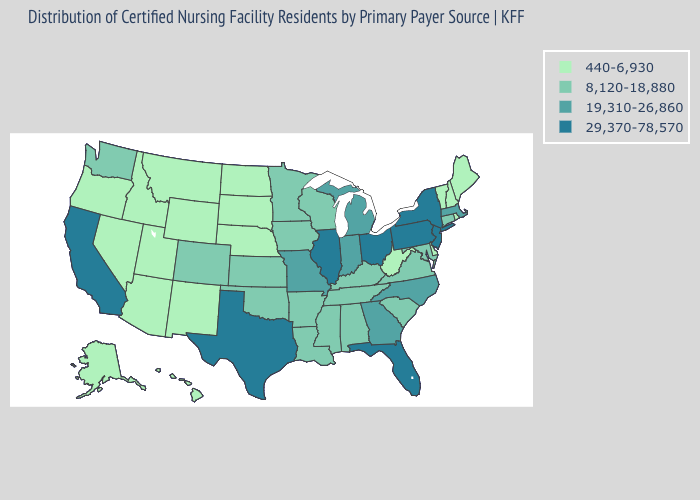Among the states that border Rhode Island , does Connecticut have the lowest value?
Quick response, please. Yes. What is the value of Pennsylvania?
Write a very short answer. 29,370-78,570. Does the first symbol in the legend represent the smallest category?
Be succinct. Yes. What is the value of Washington?
Keep it brief. 8,120-18,880. Name the states that have a value in the range 440-6,930?
Quick response, please. Alaska, Arizona, Delaware, Hawaii, Idaho, Maine, Montana, Nebraska, Nevada, New Hampshire, New Mexico, North Dakota, Oregon, Rhode Island, South Dakota, Utah, Vermont, West Virginia, Wyoming. Does the map have missing data?
Concise answer only. No. Which states have the highest value in the USA?
Keep it brief. California, Florida, Illinois, New Jersey, New York, Ohio, Pennsylvania, Texas. What is the value of Montana?
Write a very short answer. 440-6,930. Which states hav the highest value in the West?
Keep it brief. California. What is the value of South Carolina?
Answer briefly. 8,120-18,880. Name the states that have a value in the range 8,120-18,880?
Quick response, please. Alabama, Arkansas, Colorado, Connecticut, Iowa, Kansas, Kentucky, Louisiana, Maryland, Minnesota, Mississippi, Oklahoma, South Carolina, Tennessee, Virginia, Washington, Wisconsin. What is the value of Missouri?
Quick response, please. 19,310-26,860. What is the value of New Jersey?
Quick response, please. 29,370-78,570. Does the first symbol in the legend represent the smallest category?
Be succinct. Yes. How many symbols are there in the legend?
Answer briefly. 4. 